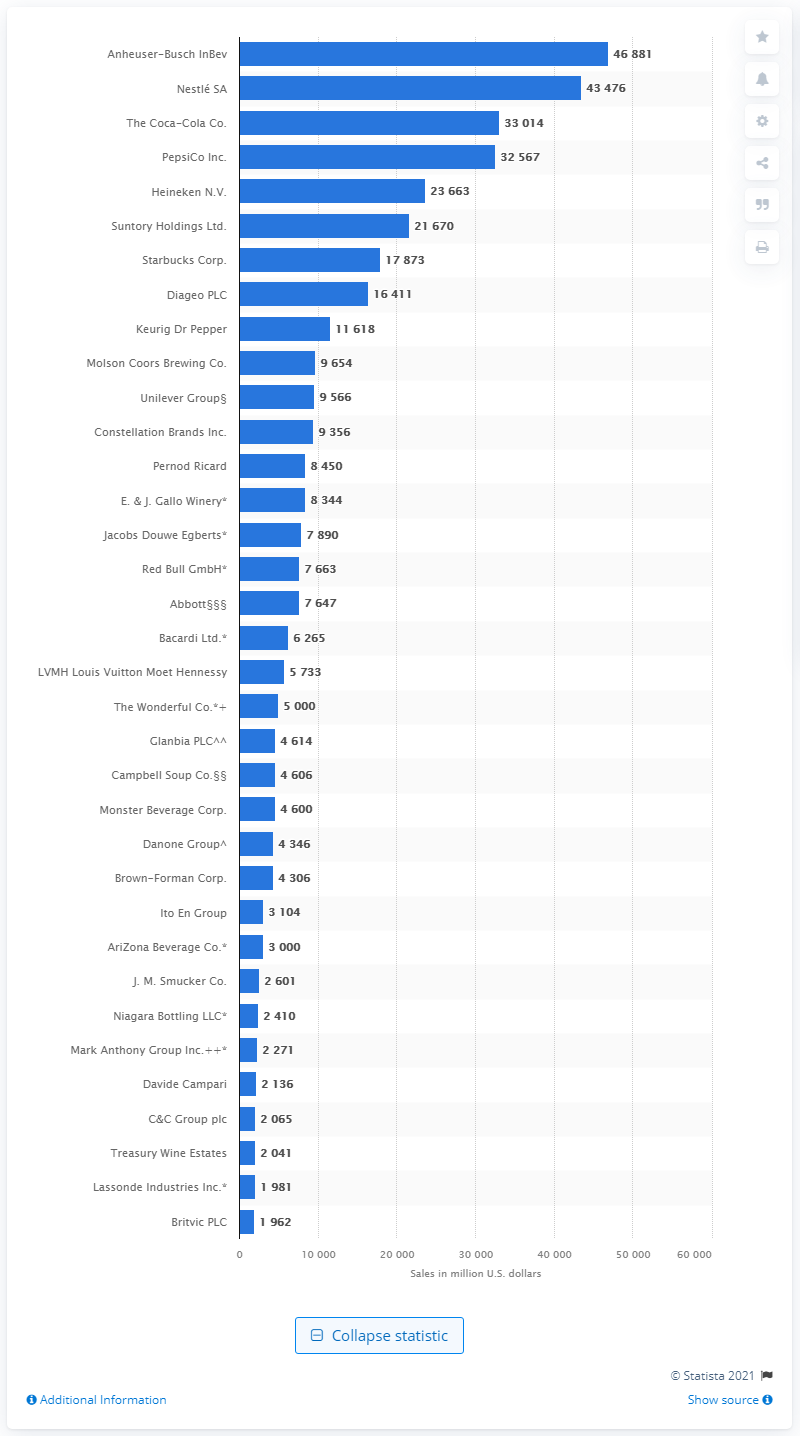Mention a couple of crucial points in this snapshot. In 2020, Anheuser-Busch InBev was the leading beverage company in the world. 